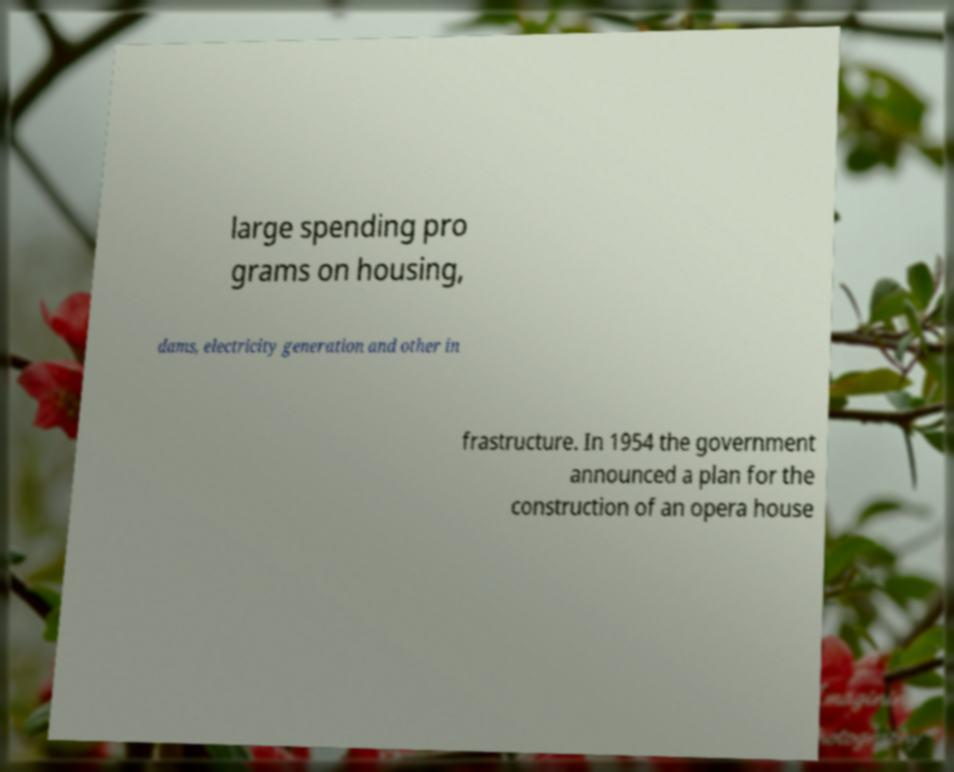Can you read and provide the text displayed in the image?This photo seems to have some interesting text. Can you extract and type it out for me? large spending pro grams on housing, dams, electricity generation and other in frastructure. In 1954 the government announced a plan for the construction of an opera house 